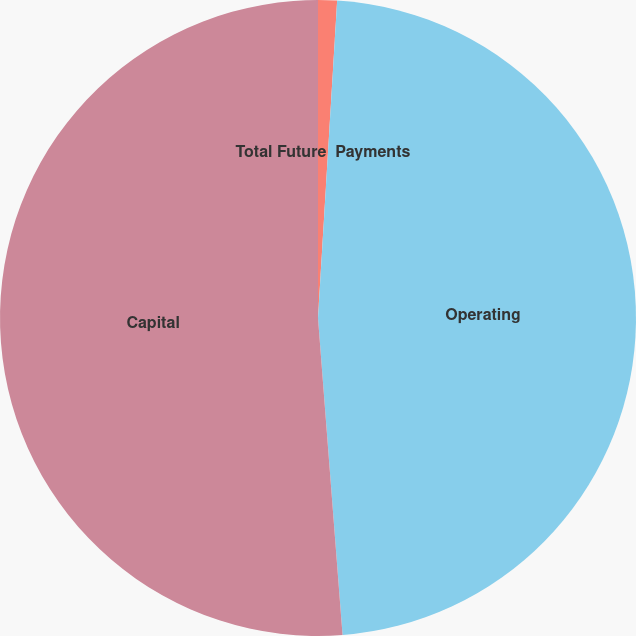<chart> <loc_0><loc_0><loc_500><loc_500><pie_chart><fcel>Total Future  Payments<fcel>Operating<fcel>Capital<nl><fcel>0.96%<fcel>47.81%<fcel>51.23%<nl></chart> 